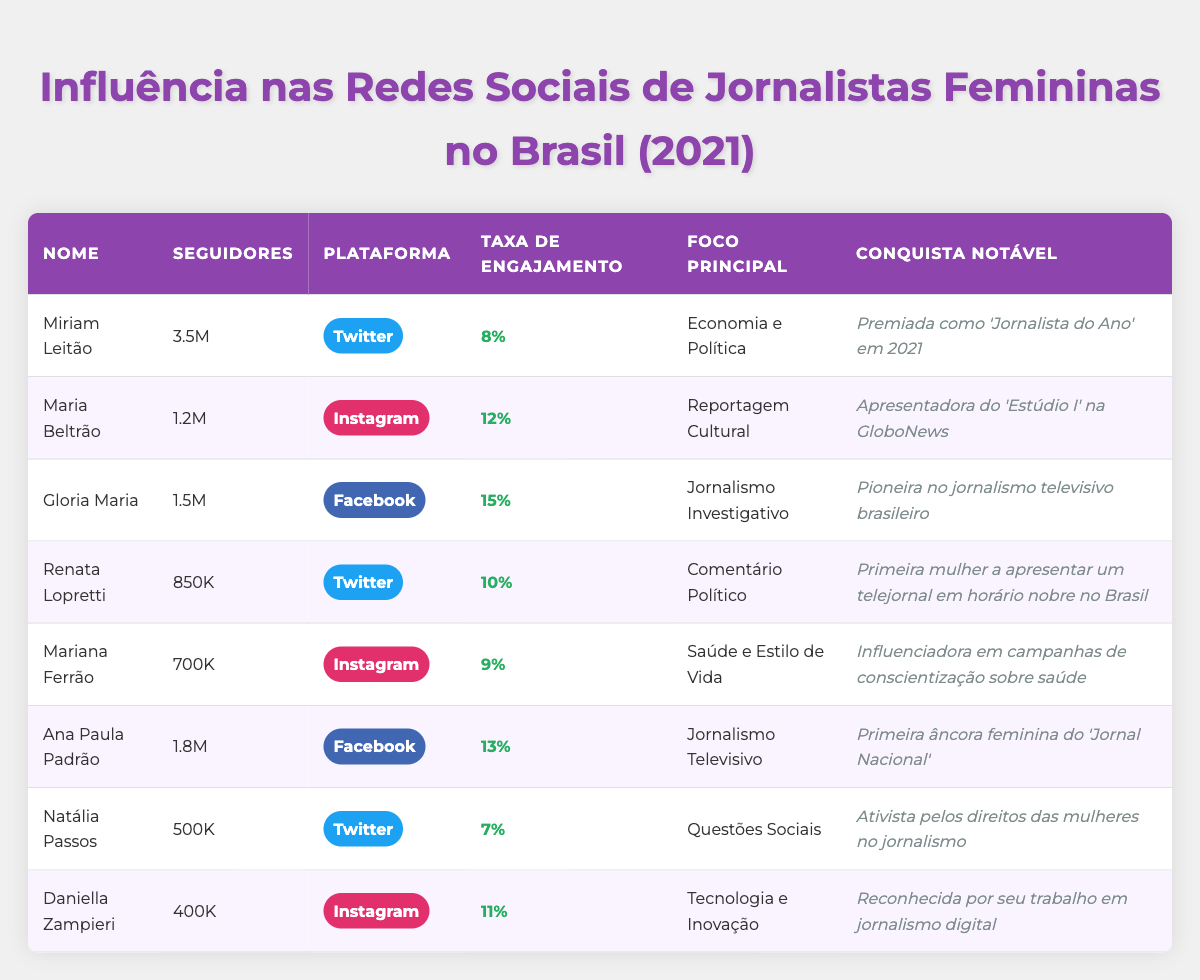What is the name of the journalist with the highest number of followers? The table lists the names of all journalists along with their followers. Miriam Leitão has 3.5 million followers, which is the highest among them.
Answer: Miriam Leitão Which platform has the highest engagement rate among the journalists? The engagement rates are listed for each journalist. Gloria Maria has the highest engagement rate at 15%.
Answer: Facebook How many total followers do the journalists on Twitter have? The followers for the Twitter users are: Miriam Leitão (3.5M), Renata Lopretti (850K), and Natália Passos (500K). Summing these gives: 3.5M + 0.85M + 0.5M = 4.85M.
Answer: 4.85 million Is there any journalist recognized for their achievements in health awareness campaigns? The notable achievements are listed, and Mariana Ferrão is recognized as an influencer in health awareness campaigns.
Answer: Yes What is the average engagement rate of the journalists listed in the table? The engagement rates are: 8%, 12%, 15%, 10%, 9%, 13%, 7%, and 11%. First, sum these rates: 8 + 12 + 15 + 10 + 9 + 13 + 7 + 11 = 85. Then, divide by the total number of journalists (8): 85/8 = 10.625%.
Answer: 10.625% Which journalist has the lowest follower count and what is their platform? By examining the followers, Daniella Zampieri has the lowest count with 400K followers on Instagram.
Answer: Daniella Zampieri, Instagram How many journalists focus on political commentary and what are their names? The table lists Renata Lopretti and Miriam Leitão as focusing on political topics. There are two journalists in this category.
Answer: 2 (Renata Lopretti, Miriam Leitão) Is Ana Paula Padrão an activist for women's rights in journalism? The notable achievements section identifies Natália Passos as an activist for women's rights, not Ana Paula Padrão.
Answer: No What is the notable achievement of the journalist with the second highest number of followers? The journalist with the second highest number of followers is Ana Paula Padrão with 1.8M followers. Her notable achievement is being the first female anchor of 'Jornal Nacional'.
Answer: First female anchor of 'Jornal Nacional' 